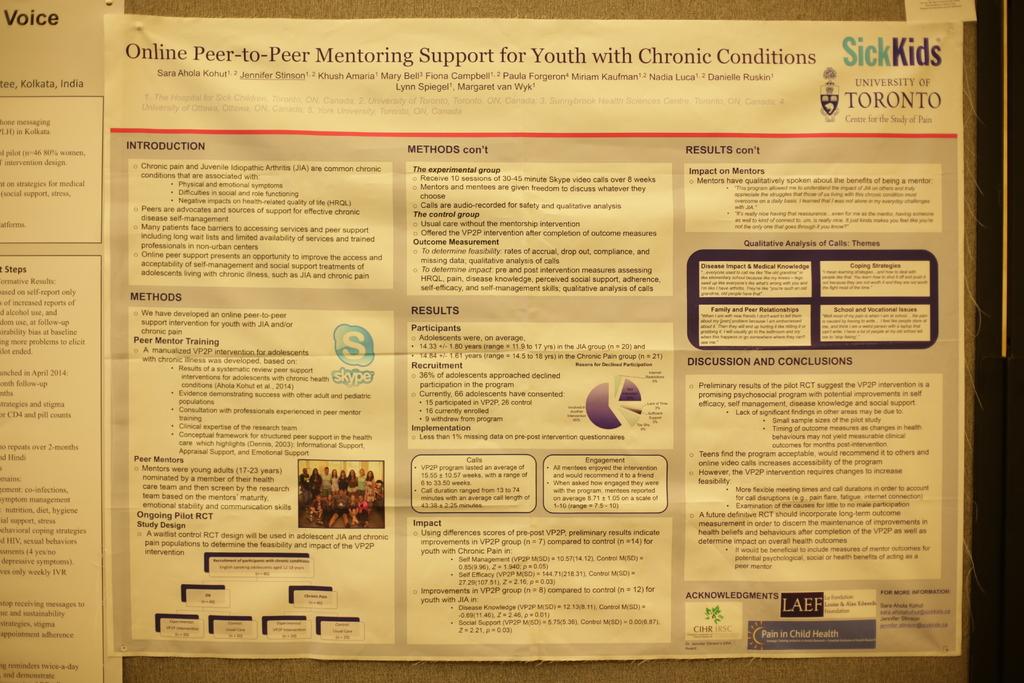What university sponsors this mentoring support?
Provide a short and direct response. University of toronto. What is the second section on the left titled?
Provide a succinct answer. Methods. 